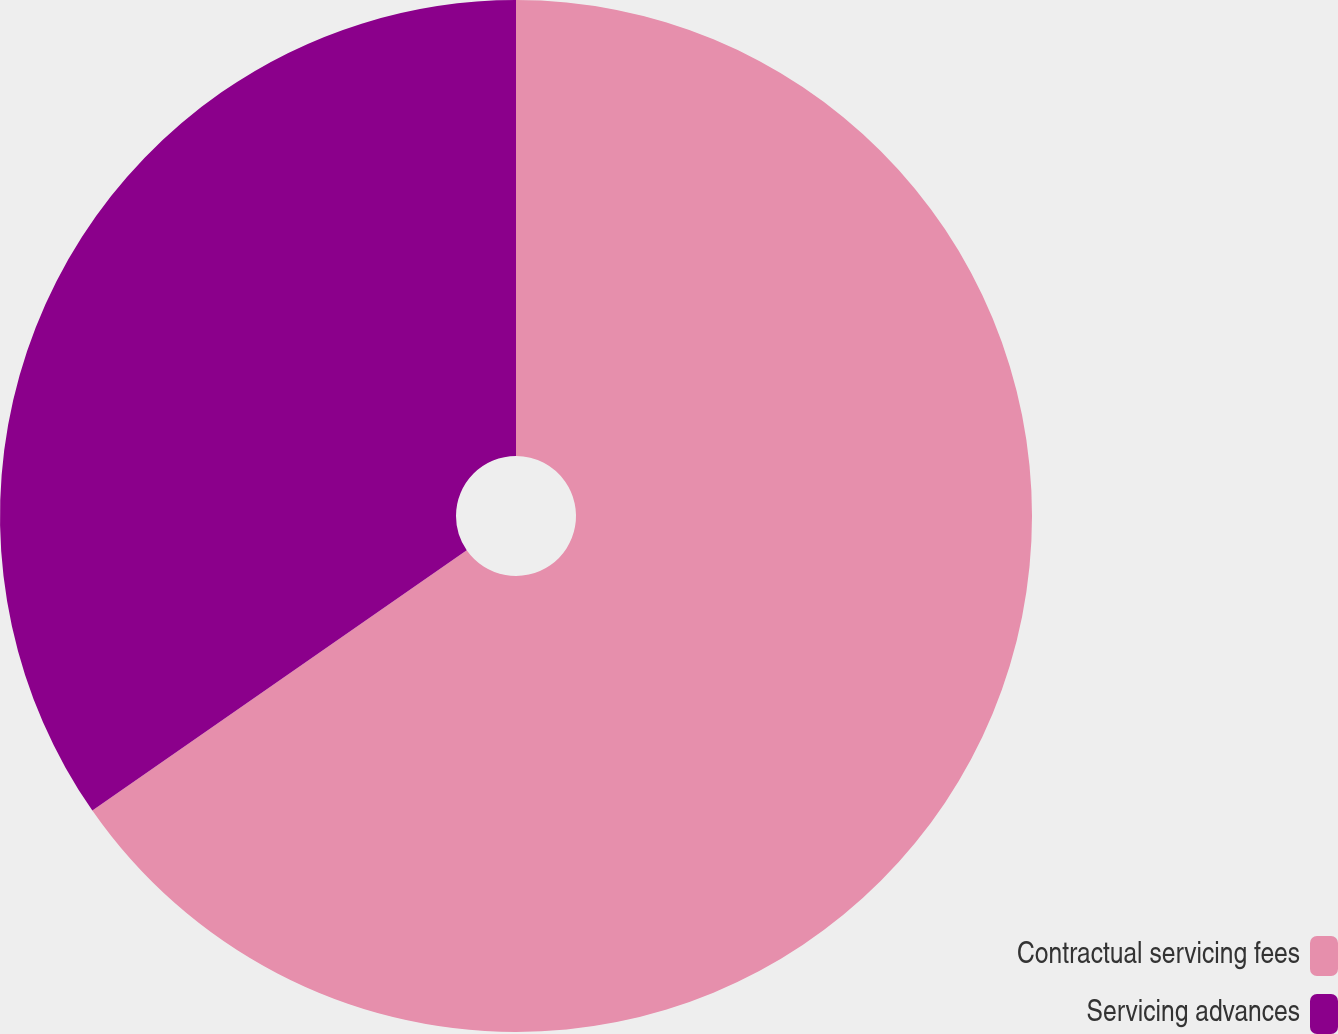<chart> <loc_0><loc_0><loc_500><loc_500><pie_chart><fcel>Contractual servicing fees<fcel>Servicing advances<nl><fcel>65.33%<fcel>34.67%<nl></chart> 